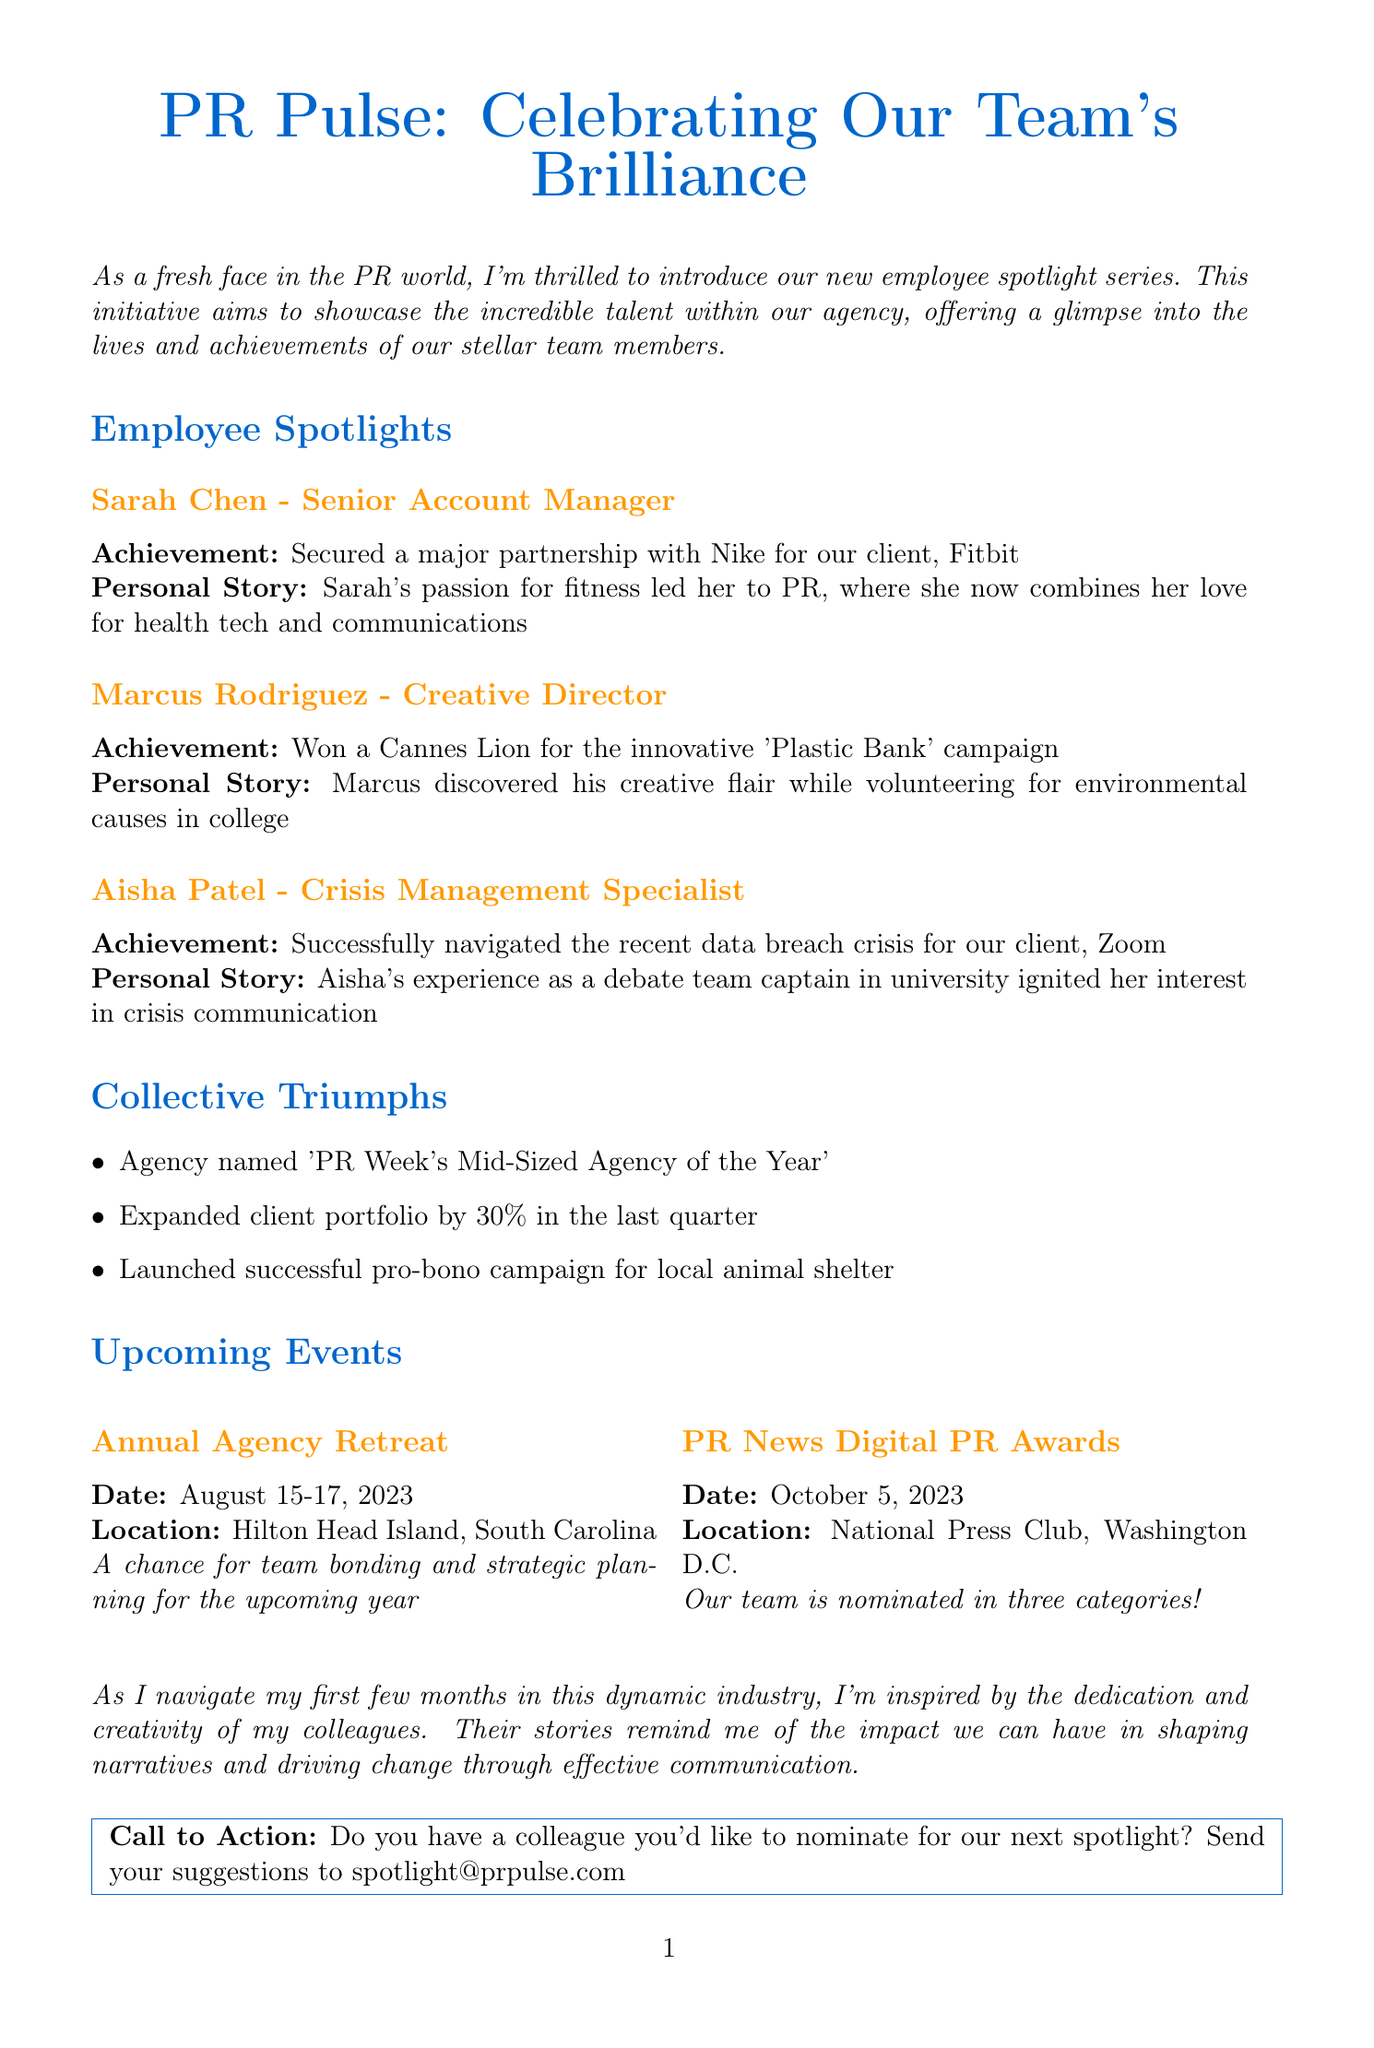What is the newsletter title? The newsletter title is prominently displayed at the top of the document, which is "PR Pulse: Celebrating Our Team's Brilliance."
Answer: PR Pulse: Celebrating Our Team's Brilliance Who is spotlighted as the Senior Account Manager? The document includes information on spotlighted employees, specifically noting Sarah Chen as the Senior Account Manager.
Answer: Sarah Chen What achievement did Marcus Rodriguez accomplish? The document highlights Marcus Rodriguez's achievement of winning a Cannes Lion for the 'Plastic Bank' campaign.
Answer: Won a Cannes Lion for the innovative 'Plastic Bank' campaign When is the Annual Agency Retreat scheduled? The schedule for the Annual Agency Retreat is clearly outlined in the upcoming events section, which states the date as August 15-17, 2023.
Answer: August 15-17, 2023 What significant award was the agency named? The specific award mentioned in the collective triumphs section is 'PR Week's Mid-Sized Agency of the Year.'
Answer: PR Week's Mid-Sized Agency of the Year What is Aisha Patel's role? Information about Aisha Patel can be found in the employee spotlight where her role is noted as Crisis Management Specialist.
Answer: Crisis Management Specialist What upcoming event features a nomination for three categories? The document specifies that the PR News Digital PR Awards event is where the team is nominated in three categories.
Answer: PR News Digital PR Awards What personal story is associated with Sarah Chen? The personal narrative about Sarah Chen is mentioned in her spotlight, stating that her passion for fitness led her to PR.
Answer: Sarah's passion for fitness led her to PR How can colleagues be nominated for the next spotlight? The call to action section explains that colleagues can be nominated by sending suggestions to spotlight@prpulse.com.
Answer: spotlight@prpulse.com 